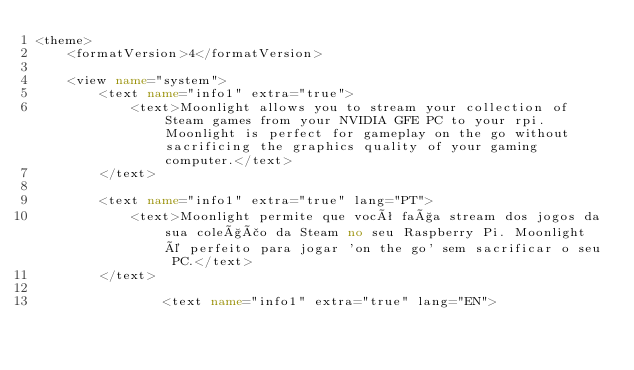<code> <loc_0><loc_0><loc_500><loc_500><_XML_><theme>
	<formatVersion>4</formatVersion>

	<view name="system">
		<text name="info1" extra="true">
			<text>Moonlight allows you to stream your collection of Steam games from your NVIDIA GFE PC to your rpi. Moonlight is perfect for gameplay on the go without sacrificing the graphics quality of your gaming computer.</text>
		</text>

		<text name="info1" extra="true" lang="PT">
			<text>Moonlight permite que você faça stream dos jogos da sua coleção da Steam no seu Raspberry Pi. Moonlight é perfeito para jogar 'on the go' sem sacrificar o seu PC.</text>
		</text>

				<text name="info1" extra="true" lang="EN"></code> 